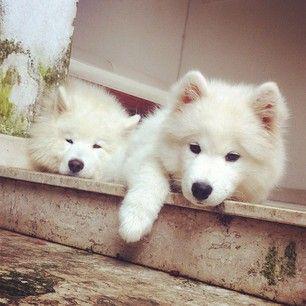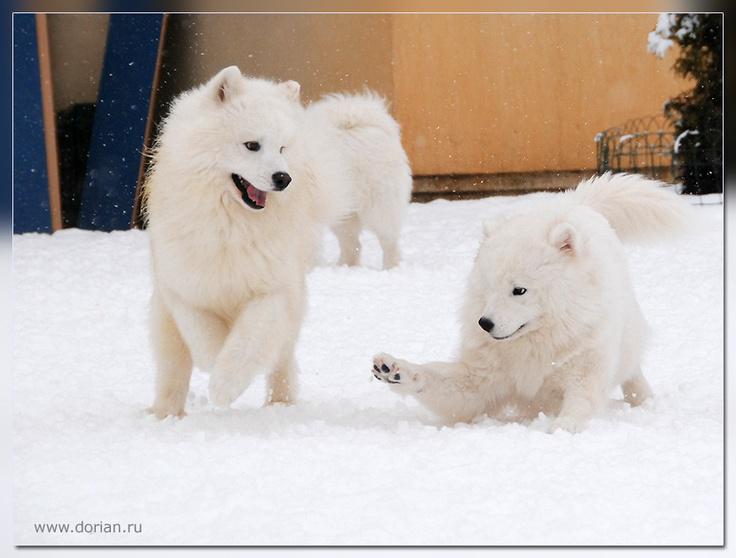The first image is the image on the left, the second image is the image on the right. Analyze the images presented: Is the assertion "There are at most 2 dogs in the image pair" valid? Answer yes or no. No. The first image is the image on the left, the second image is the image on the right. For the images displayed, is the sentence "There are at most two dogs." factually correct? Answer yes or no. No. The first image is the image on the left, the second image is the image on the right. Considering the images on both sides, is "There are two dogs in total." valid? Answer yes or no. No. The first image is the image on the left, the second image is the image on the right. For the images displayed, is the sentence "An image shows a white dog with something edible in front of him." factually correct? Answer yes or no. No. 